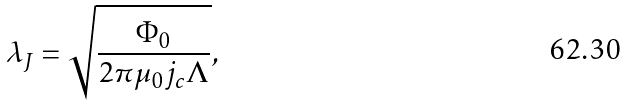Convert formula to latex. <formula><loc_0><loc_0><loc_500><loc_500>\lambda _ { J } = \sqrt { \frac { \Phi _ { 0 } } { 2 \pi \mu _ { 0 } j _ { c } \Lambda } } ,</formula> 